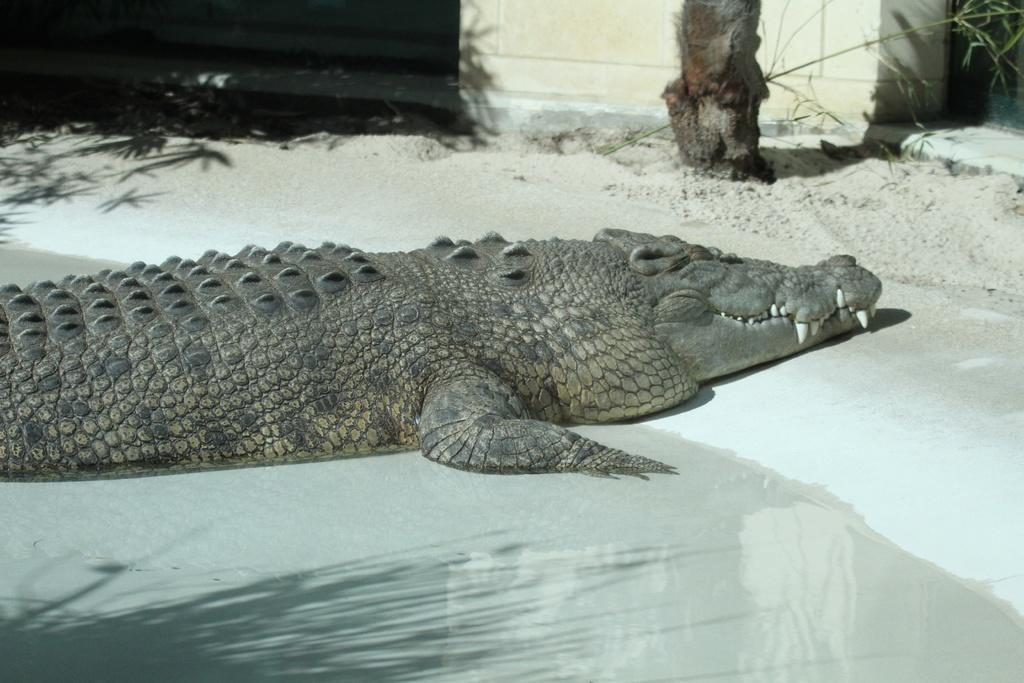Describe this image in one or two sentences. In the picture we can see a crocodile with its some part in water and some part outside the water on the sand and in the background we can see a wall near it we can see a part of the tree. 